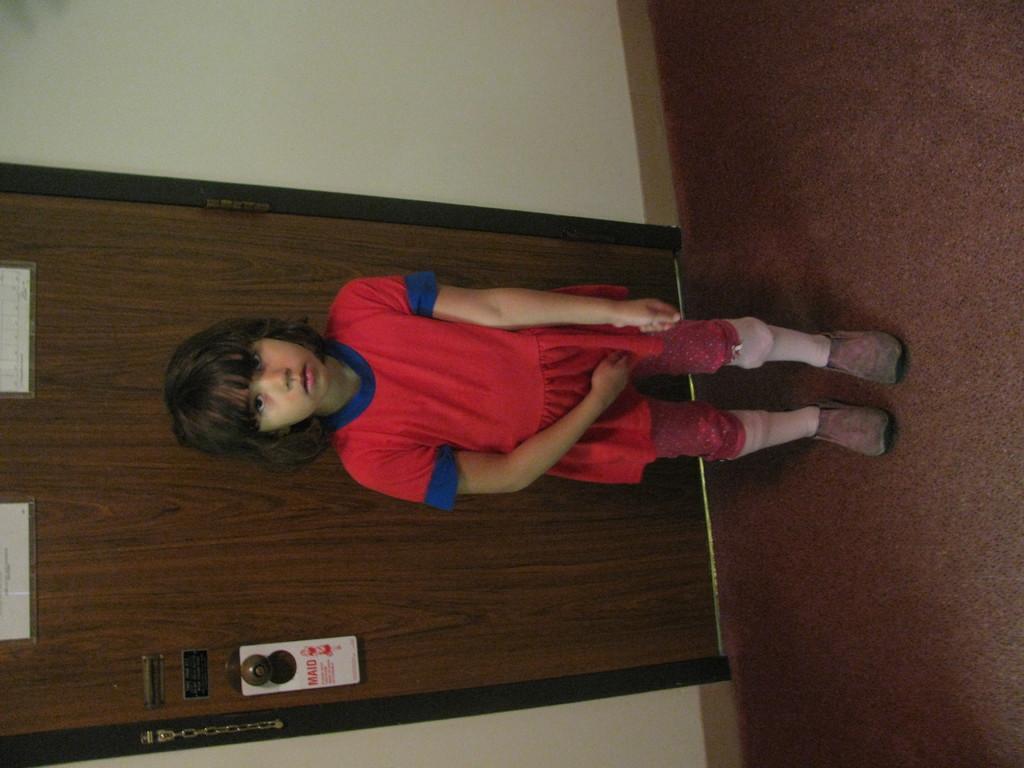In one or two sentences, can you explain what this image depicts? In this picture we can observe a girl standing, wearing red color dress. Behind the dress there is a brown color door. We can observe a wall in the background. The girl is standing on the brown color floor. 